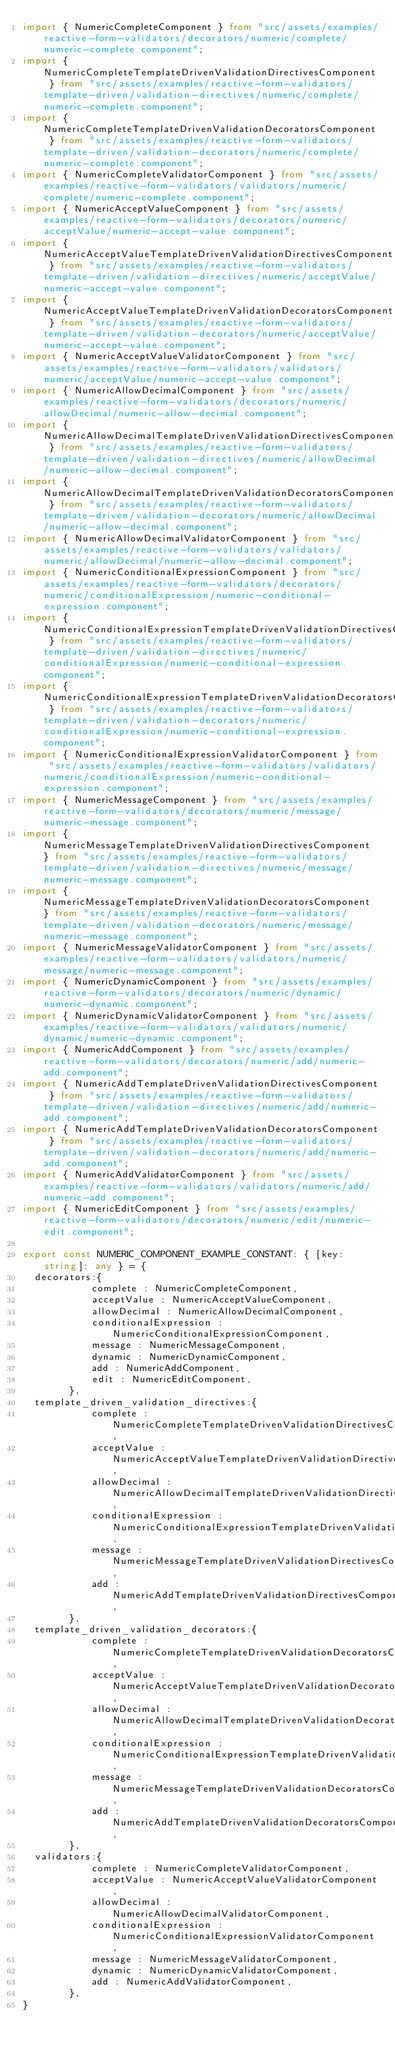<code> <loc_0><loc_0><loc_500><loc_500><_TypeScript_>import { NumericCompleteComponent } from "src/assets/examples/reactive-form-validators/decorators/numeric/complete/numeric-complete.component";
import { NumericCompleteTemplateDrivenValidationDirectivesComponent } from "src/assets/examples/reactive-form-validators/template-driven/validation-directives/numeric/complete/numeric-complete.component";
import { NumericCompleteTemplateDrivenValidationDecoratorsComponent } from "src/assets/examples/reactive-form-validators/template-driven/validation-decorators/numeric/complete/numeric-complete.component";
import { NumericCompleteValidatorComponent } from "src/assets/examples/reactive-form-validators/validators/numeric/complete/numeric-complete.component";
import { NumericAcceptValueComponent } from "src/assets/examples/reactive-form-validators/decorators/numeric/acceptValue/numeric-accept-value.component";
import { NumericAcceptValueTemplateDrivenValidationDirectivesComponent } from "src/assets/examples/reactive-form-validators/template-driven/validation-directives/numeric/acceptValue/numeric-accept-value.component";
import { NumericAcceptValueTemplateDrivenValidationDecoratorsComponent } from "src/assets/examples/reactive-form-validators/template-driven/validation-decorators/numeric/acceptValue/numeric-accept-value.component";
import { NumericAcceptValueValidatorComponent } from "src/assets/examples/reactive-form-validators/validators/numeric/acceptValue/numeric-accept-value.component";
import { NumericAllowDecimalComponent } from "src/assets/examples/reactive-form-validators/decorators/numeric/allowDecimal/numeric-allow-decimal.component";
import { NumericAllowDecimalTemplateDrivenValidationDirectivesComponent } from "src/assets/examples/reactive-form-validators/template-driven/validation-directives/numeric/allowDecimal/numeric-allow-decimal.component";
import { NumericAllowDecimalTemplateDrivenValidationDecoratorsComponent } from "src/assets/examples/reactive-form-validators/template-driven/validation-decorators/numeric/allowDecimal/numeric-allow-decimal.component";
import { NumericAllowDecimalValidatorComponent } from "src/assets/examples/reactive-form-validators/validators/numeric/allowDecimal/numeric-allow-decimal.component";
import { NumericConditionalExpressionComponent } from "src/assets/examples/reactive-form-validators/decorators/numeric/conditionalExpression/numeric-conditional-expression.component";
import { NumericConditionalExpressionTemplateDrivenValidationDirectivesComponent } from "src/assets/examples/reactive-form-validators/template-driven/validation-directives/numeric/conditionalExpression/numeric-conditional-expression.component";
import { NumericConditionalExpressionTemplateDrivenValidationDecoratorsComponent } from "src/assets/examples/reactive-form-validators/template-driven/validation-decorators/numeric/conditionalExpression/numeric-conditional-expression.component";
import { NumericConditionalExpressionValidatorComponent } from "src/assets/examples/reactive-form-validators/validators/numeric/conditionalExpression/numeric-conditional-expression.component";
import { NumericMessageComponent } from "src/assets/examples/reactive-form-validators/decorators/numeric/message/numeric-message.component";
import { NumericMessageTemplateDrivenValidationDirectivesComponent } from "src/assets/examples/reactive-form-validators/template-driven/validation-directives/numeric/message/numeric-message.component";
import { NumericMessageTemplateDrivenValidationDecoratorsComponent } from "src/assets/examples/reactive-form-validators/template-driven/validation-decorators/numeric/message/numeric-message.component";
import { NumericMessageValidatorComponent } from "src/assets/examples/reactive-form-validators/validators/numeric/message/numeric-message.component";
import { NumericDynamicComponent } from "src/assets/examples/reactive-form-validators/decorators/numeric/dynamic/numeric-dynamic.component";
import { NumericDynamicValidatorComponent } from "src/assets/examples/reactive-form-validators/validators/numeric/dynamic/numeric-dynamic.component";
import { NumericAddComponent } from "src/assets/examples/reactive-form-validators/decorators/numeric/add/numeric-add.component";
import { NumericAddTemplateDrivenValidationDirectivesComponent } from "src/assets/examples/reactive-form-validators/template-driven/validation-directives/numeric/add/numeric-add.component";
import { NumericAddTemplateDrivenValidationDecoratorsComponent } from "src/assets/examples/reactive-form-validators/template-driven/validation-decorators/numeric/add/numeric-add.component";
import { NumericAddValidatorComponent } from "src/assets/examples/reactive-form-validators/validators/numeric/add/numeric-add.component";
import { NumericEditComponent } from "src/assets/examples/reactive-form-validators/decorators/numeric/edit/numeric-edit.component";

export const NUMERIC_COMPONENT_EXAMPLE_CONSTANT: { [key: string]: any } = {
	decorators:{
						complete : NumericCompleteComponent,
						acceptValue : NumericAcceptValueComponent,
						allowDecimal : NumericAllowDecimalComponent,
						conditionalExpression : NumericConditionalExpressionComponent,
						message : NumericMessageComponent,
						dynamic : NumericDynamicComponent,
						add : NumericAddComponent,
						edit : NumericEditComponent,
			  },
	template_driven_validation_directives:{
						complete : NumericCompleteTemplateDrivenValidationDirectivesComponent,
						acceptValue : NumericAcceptValueTemplateDrivenValidationDirectivesComponent,
						allowDecimal : NumericAllowDecimalTemplateDrivenValidationDirectivesComponent,
						conditionalExpression : NumericConditionalExpressionTemplateDrivenValidationDirectivesComponent,
						message : NumericMessageTemplateDrivenValidationDirectivesComponent,
						add : NumericAddTemplateDrivenValidationDirectivesComponent,
			  },
	template_driven_validation_decorators:{
						complete : NumericCompleteTemplateDrivenValidationDecoratorsComponent,
						acceptValue : NumericAcceptValueTemplateDrivenValidationDecoratorsComponent,
						allowDecimal : NumericAllowDecimalTemplateDrivenValidationDecoratorsComponent,
						conditionalExpression : NumericConditionalExpressionTemplateDrivenValidationDecoratorsComponent,
						message : NumericMessageTemplateDrivenValidationDecoratorsComponent,
						add : NumericAddTemplateDrivenValidationDecoratorsComponent,
			  },
	validators:{
						complete : NumericCompleteValidatorComponent,
						acceptValue : NumericAcceptValueValidatorComponent,
						allowDecimal : NumericAllowDecimalValidatorComponent,
						conditionalExpression : NumericConditionalExpressionValidatorComponent,
						message : NumericMessageValidatorComponent,
						dynamic : NumericDynamicValidatorComponent,
						add : NumericAddValidatorComponent,
			  },
}</code> 